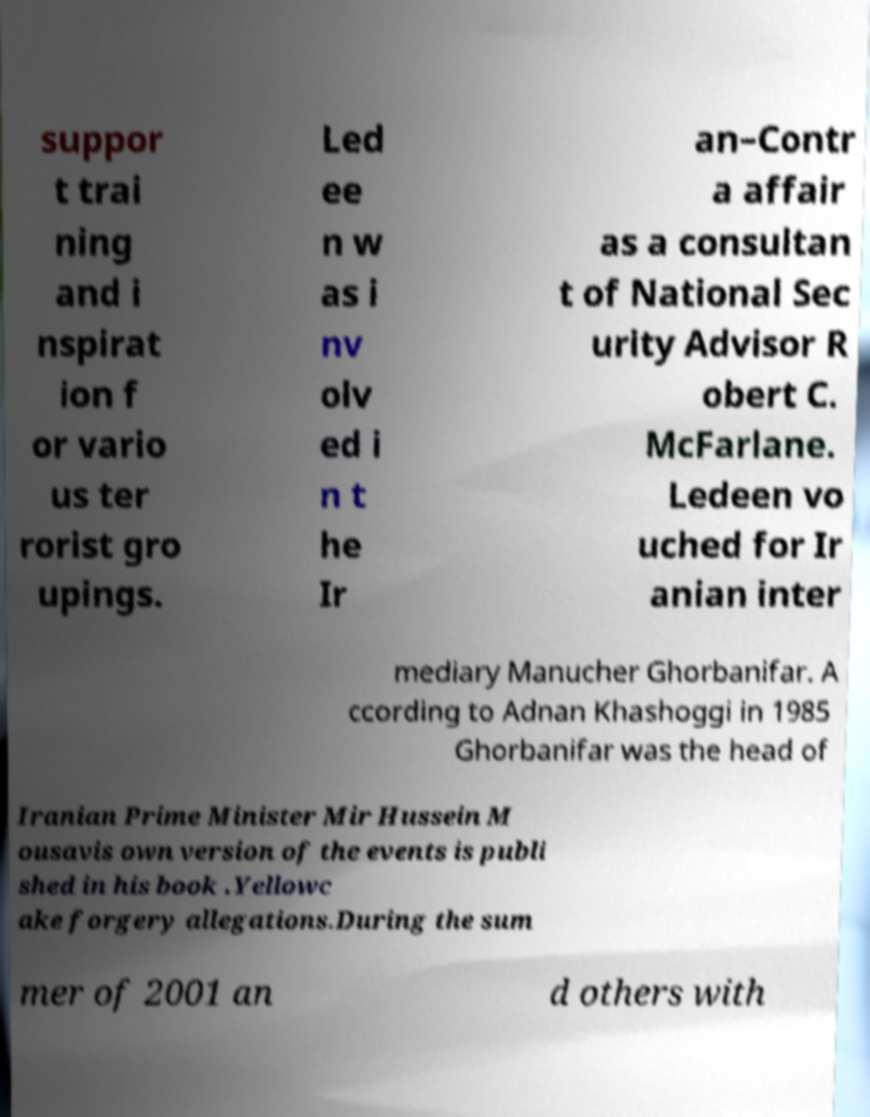Please read and relay the text visible in this image. What does it say? suppor t trai ning and i nspirat ion f or vario us ter rorist gro upings. Led ee n w as i nv olv ed i n t he Ir an–Contr a affair as a consultan t of National Sec urity Advisor R obert C. McFarlane. Ledeen vo uched for Ir anian inter mediary Manucher Ghorbanifar. A ccording to Adnan Khashoggi in 1985 Ghorbanifar was the head of Iranian Prime Minister Mir Hussein M ousavis own version of the events is publi shed in his book .Yellowc ake forgery allegations.During the sum mer of 2001 an d others with 